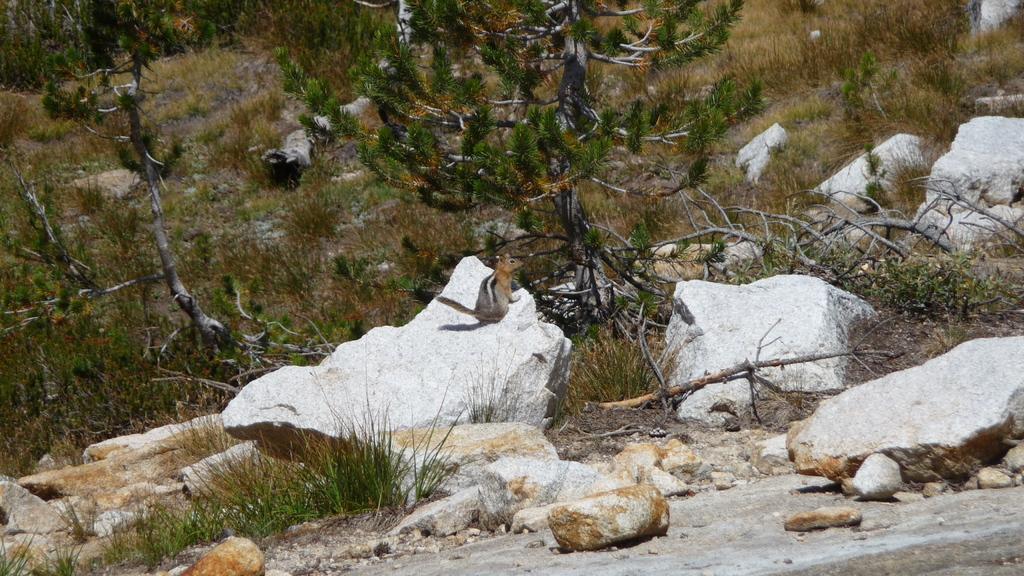Can you describe this image briefly? On this rock there is a squirrel. In this image we can see rocks, branches, grass and trees. 